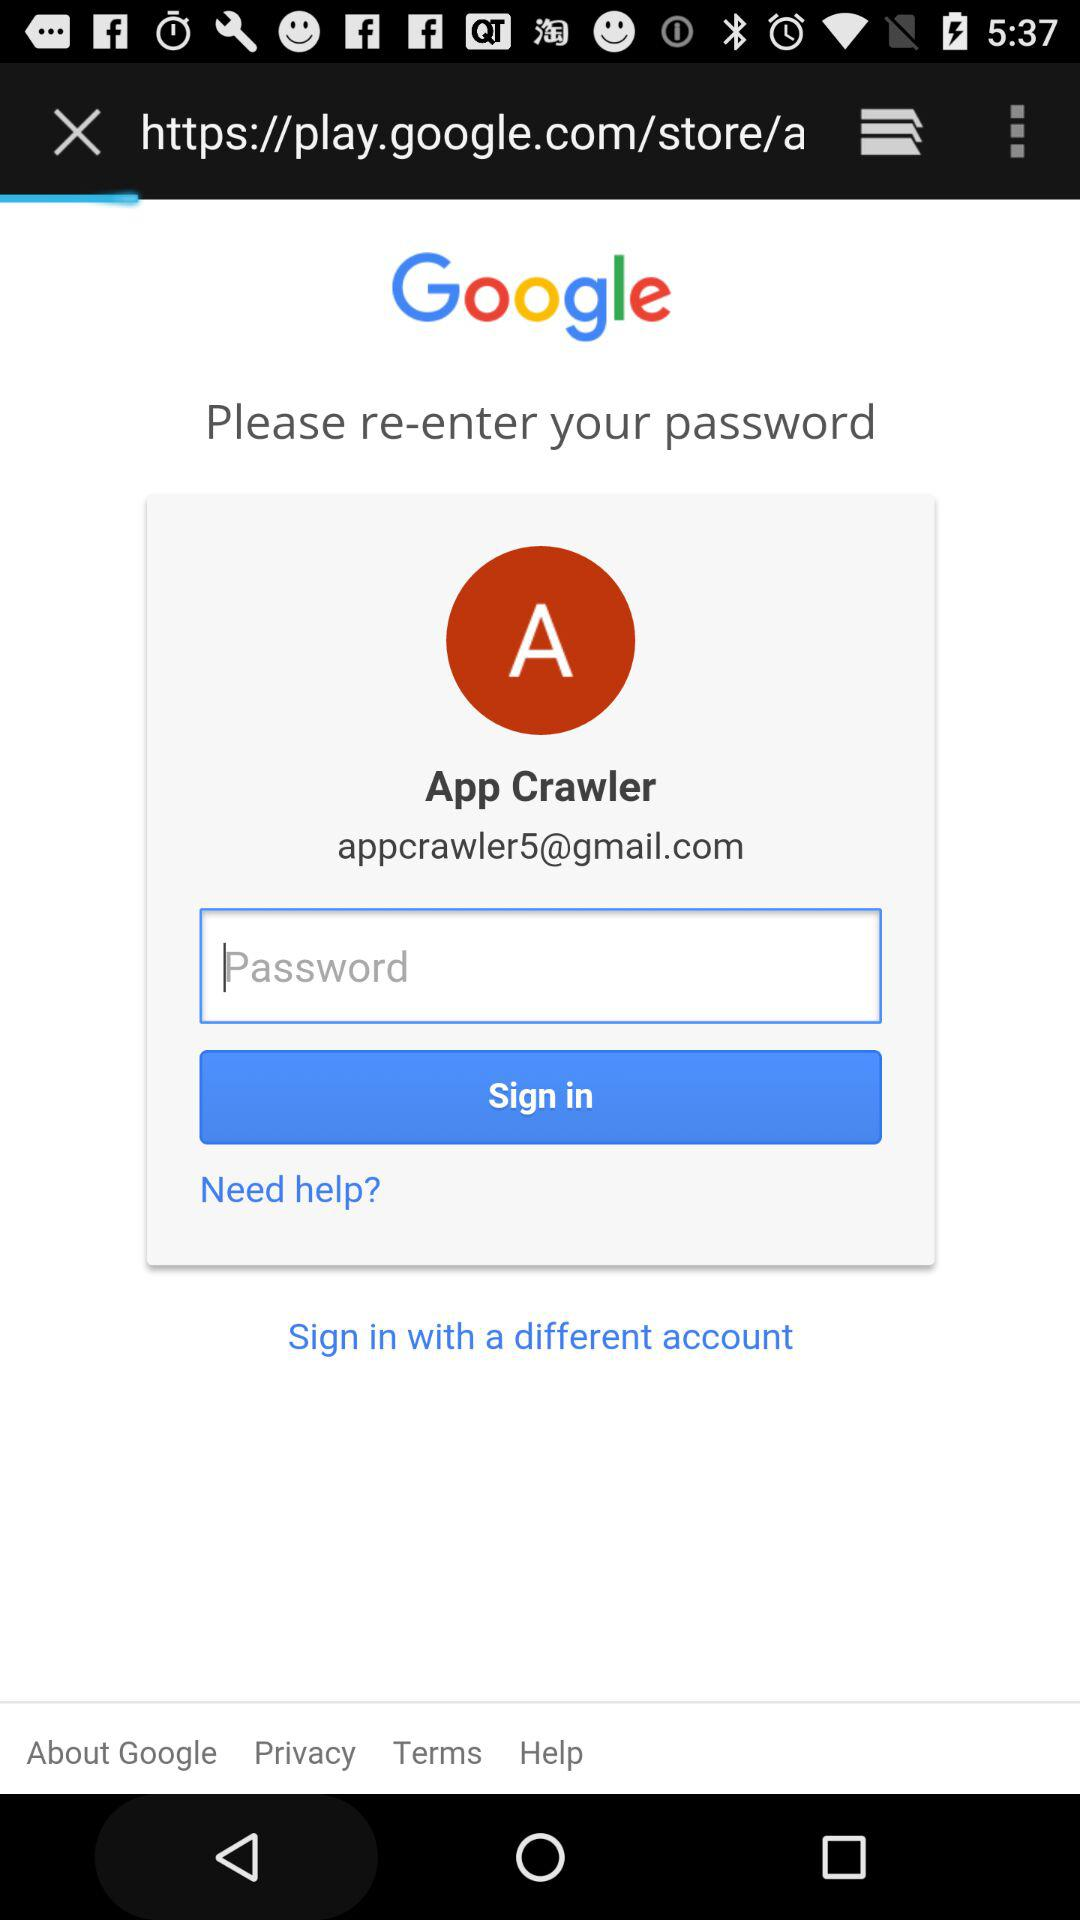What is the email address? The email address is appcrawler5@gmail.com. 